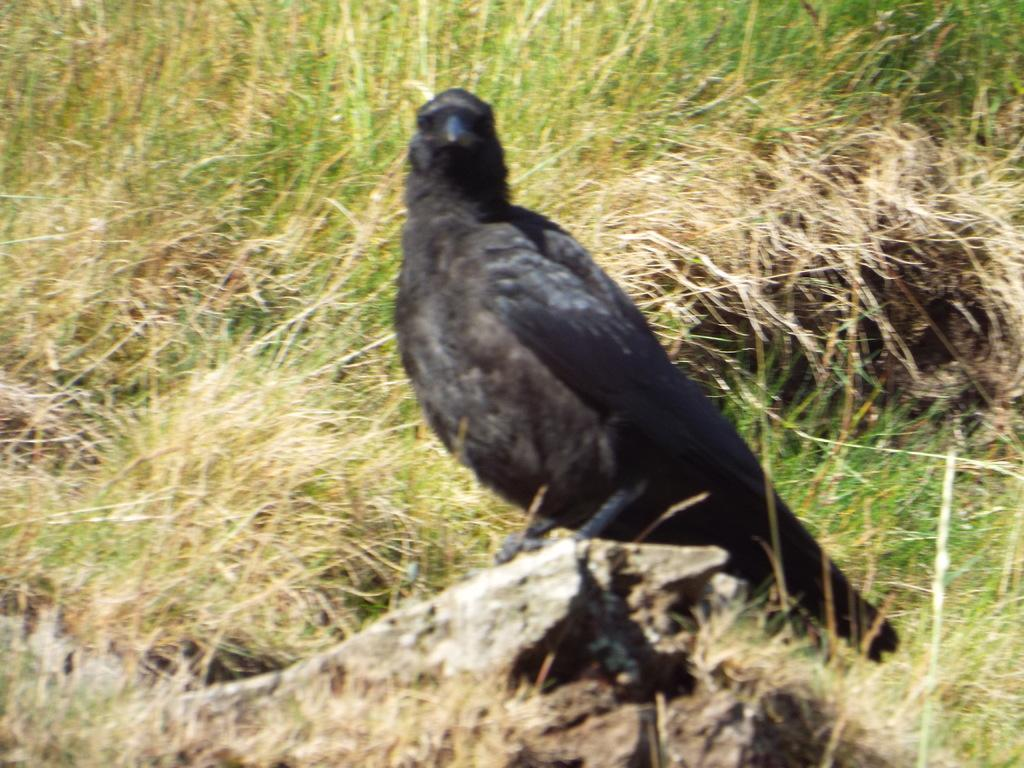What type of bird is in the image? There is a crow in the image. Where is the crow located? The crow is on a rock. What can be seen in the background of the image? There is grass in the background of the image. What type of bird is attempting to light a flame in the image? There is no bird attempting to light a flame in the image; it only features a crow on a rock with grass in the background. 